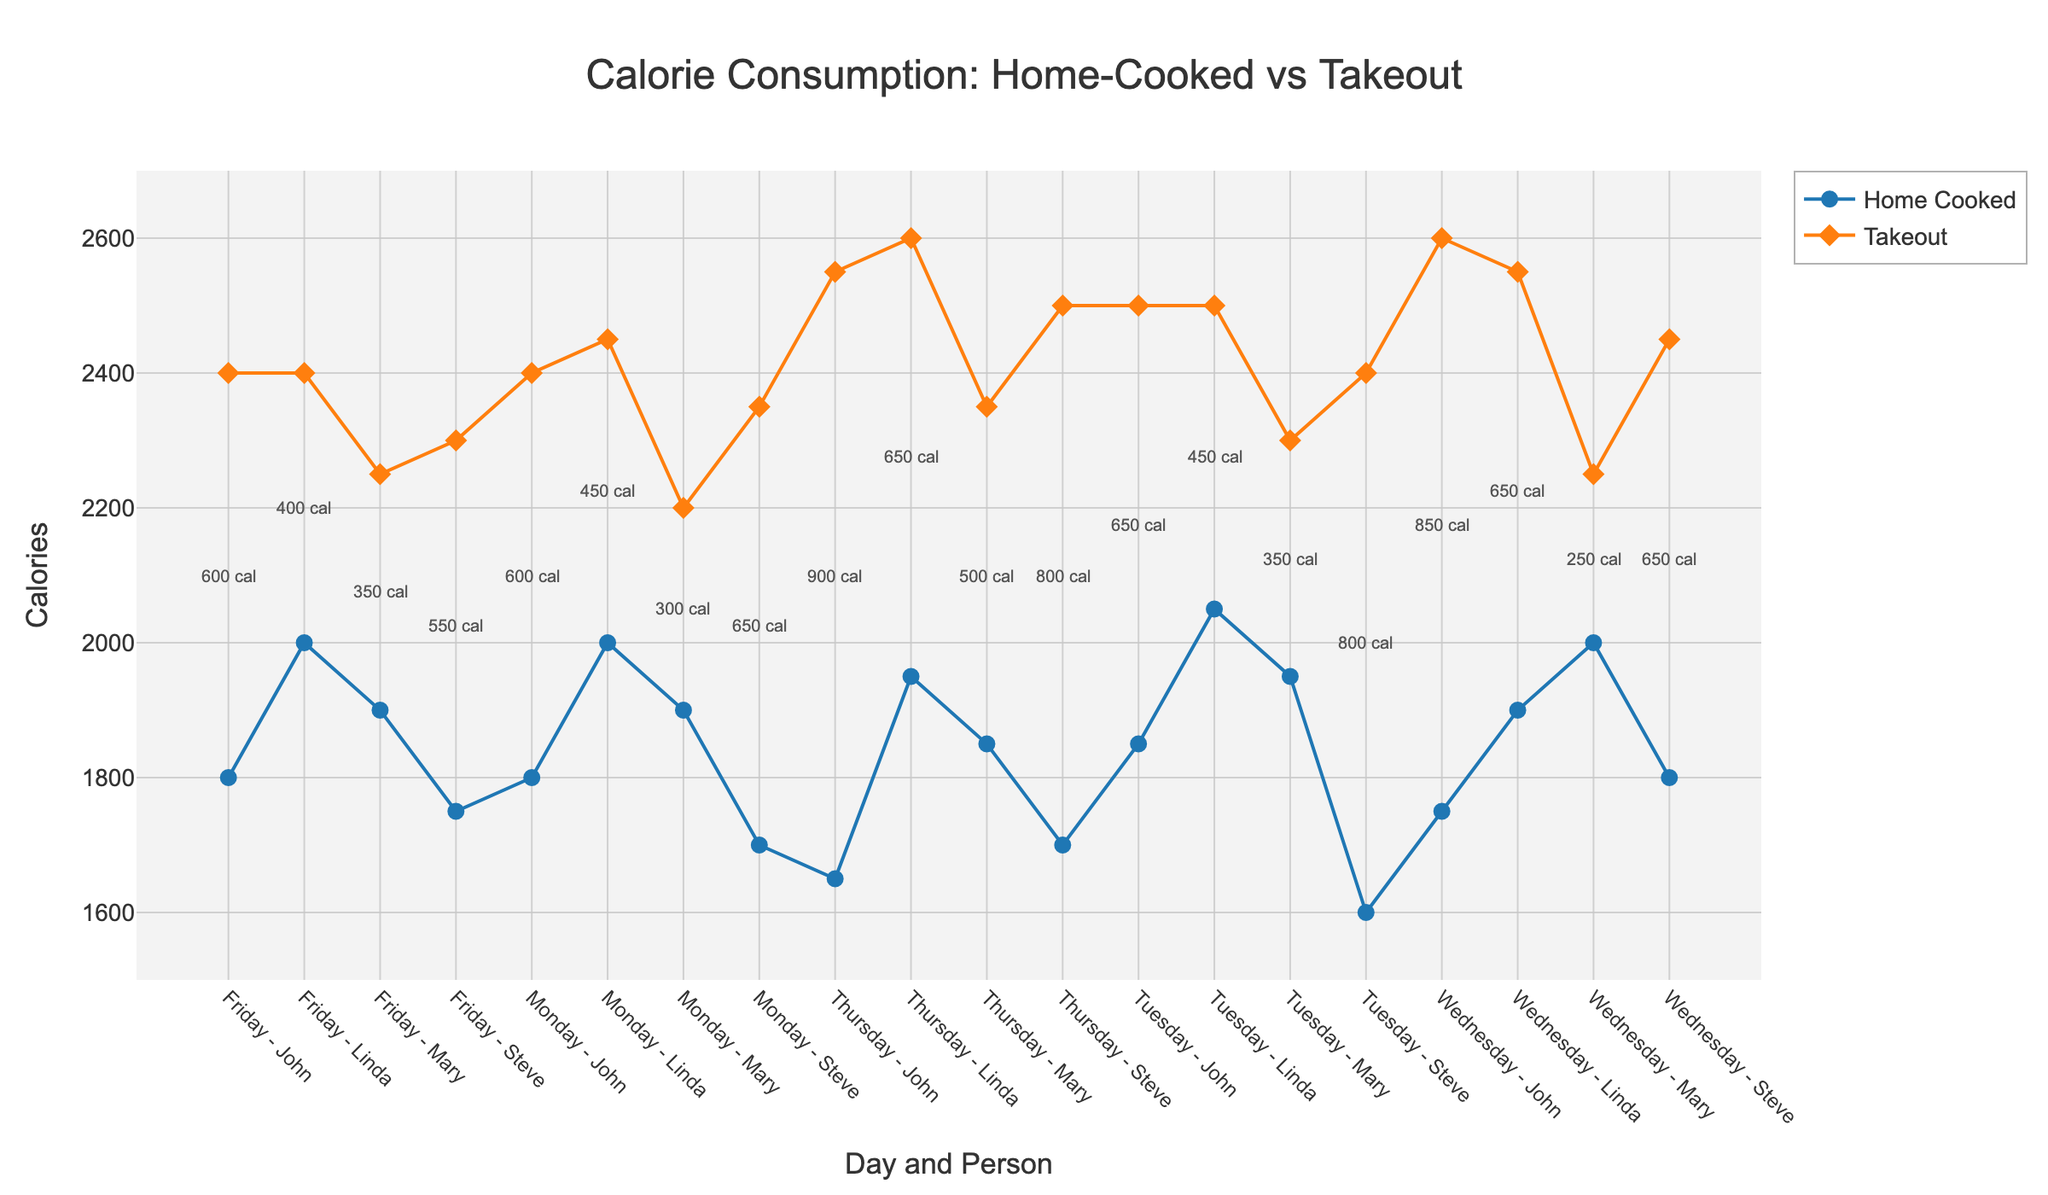what is the title of the plot? The title is located at the top center of the plot. It summarizes the content of the figure.
Answer: Calorie Consumption: Home-Cooked vs Takeout how many different people are shown in the plot? There are four distinct names used in the plot: John, Mary, Steve, and Linda.
Answer: 4 on which day does John consume the highest number of takeout calories? By looking at the takeout calories for John across the days, the highest takeout calories are observed on Wednesday.
Answer: Wednesday what is the difference in calorie consumption between home-cooked and takeout meals for Steve on Tuesday? Steve's home-cooked calories on Tuesday are 1600 and takeout calories are 2400. The difference is 2400 - 1600 = 800.
Answer: 800 which individual consistently consumes more takeout calories than home-cooked calories across all days? By comparing calories each day for each individual, Linda consistently has higher takeout calories than home-cooked calories from Monday to Friday.
Answer: Linda what is the average calorie consumption for John from home-cooked meals over the week? Sum of John's home-cooked calories from Monday to Friday is (1800 + 1850 + 1750 + 1650 + 1800). Total is 8850. Average is 8850 / 5 = 1770.
Answer: 1770 comparing Steve and Linda, who consumes more total calories from takeout meals for the entire week? Sum of Steve's takeout calories = (2350 + 2400 + 2450 + 2500 + 2300) = 12000. Sum of Linda's takeout calories = (2450 + 2500 + 2550 + 2600 + 2400) = 12500.
Answer: Linda what is the range of calorie values for the takeout meals plotted? The minimum takeout calorie value is 2200 (Mary on Monday) and the maximum is 2600 (John on Wednesday and Linda on Thursday). The range is 2600 - 2200 = 400.
Answer: 400 what is the least difference in calorie consumption between home-cooked and takeout meals, and for whom and on which day is this observed? The least difference can be observed by analyzing all the annotations between the points. The smallest annotation is 150 cal for Mary on Tuesday.
Answer: 150 cal, Mary, Tuesday 